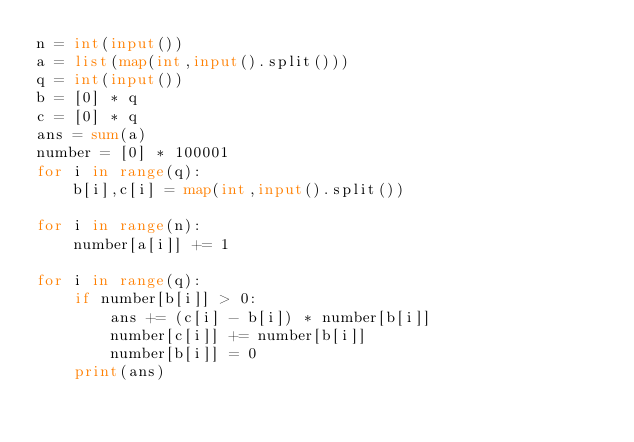Convert code to text. <code><loc_0><loc_0><loc_500><loc_500><_Python_>n = int(input())
a = list(map(int,input().split()))
q = int(input())
b = [0] * q
c = [0] * q
ans = sum(a)
number = [0] * 100001
for i in range(q):
    b[i],c[i] = map(int,input().split())

for i in range(n):
    number[a[i]] += 1

for i in range(q):
    if number[b[i]] > 0:
        ans += (c[i] - b[i]) * number[b[i]]
        number[c[i]] += number[b[i]]    
        number[b[i]] = 0
    print(ans)</code> 